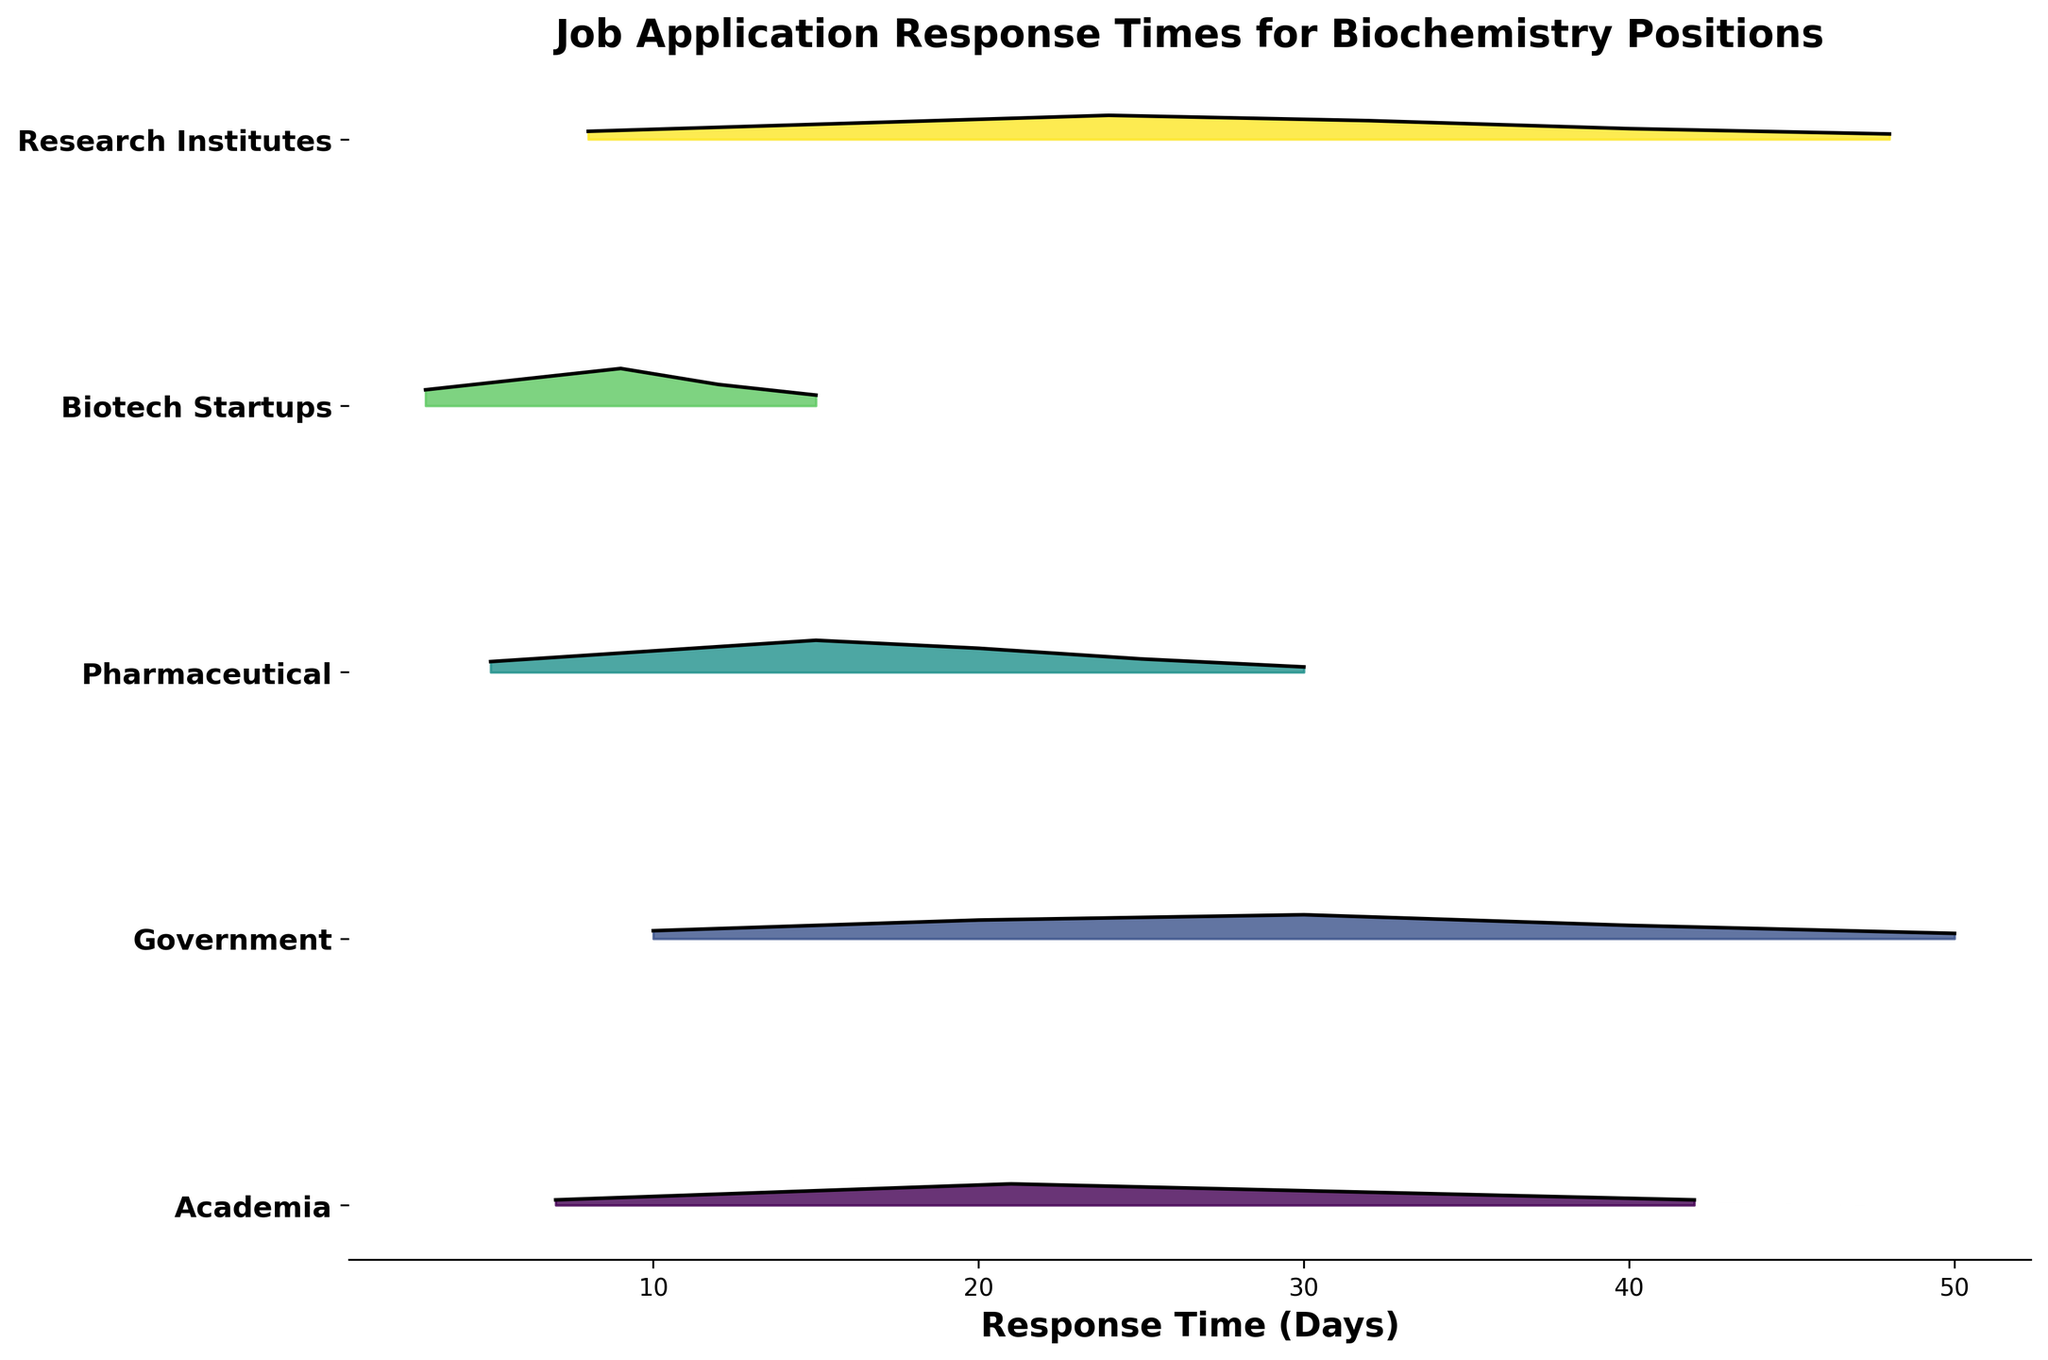What is the title of the plot? The title is displayed prominently at the top of the plot, indicating the subject of the data.
Answer: Job Application Response Times for Biochemistry Positions How many sectors are represented in the plot? Counting the unique labels on the Y-axis provides the number of sectors.
Answer: Five Which sector shows the highest density peak for job application response times around 10 days? Observing the height and placement of the peaks, the tallest peak around 10 days can be identified.
Answer: Biotech Startups What is the general trend for the response times in the academic sector? Analyzing the ridgeline of the Academia sector provides insight into the density distribution over time. The peaks and slopes indicate the common response times.
Answer: Peaks at 21 days, with a decreasing trend afterward Which sector has the shortest response time peak? By checking the minimum X-axis value where the density starts to rise significantly, the corresponding sector can be identified.
Answer: Biotech Startups Compare the density of response times at 20 days for Government and Pharmaceutical sectors. Which one has a higher density? Look at the height of the ridgeline lines at the 20-day mark for both sectors, comparing which is higher.
Answer: Pharmaceutical Among the displayed sectors, which one tends to have the longest waiting times for job application responses? Examine the X-axis values where the density line plateaus or extends further to the right, indicating longer response times.
Answer: Government What is the most common response time for job applications in the Research Institutes sector? Locate the highest peak within the Research Institutes ridgeline, which corresponds to the most frequent response time.
Answer: 24 days How does the width of the peaks compare between the Biotech Startups and Pharmaceutical sectors? Compare the spread of the density peaks along the X-axis for both sectors, noting which has a wider versus narrower spread.
Answer: Biotech Startups have wider peaks than Pharmaceutical What is the average peak response time across all sectors? Calculate the average by summing up the peak response times of each sector and dividing by the number of sectors. Peaks are at 21 (Academia), 30 (Government), 15 (Pharmaceutical), 9 (Biotech Startups), and 24 (Research Institutes). (21+30+15+9+24)/5 = 99/5 = 19.8 days.
Answer: 19.8 days 